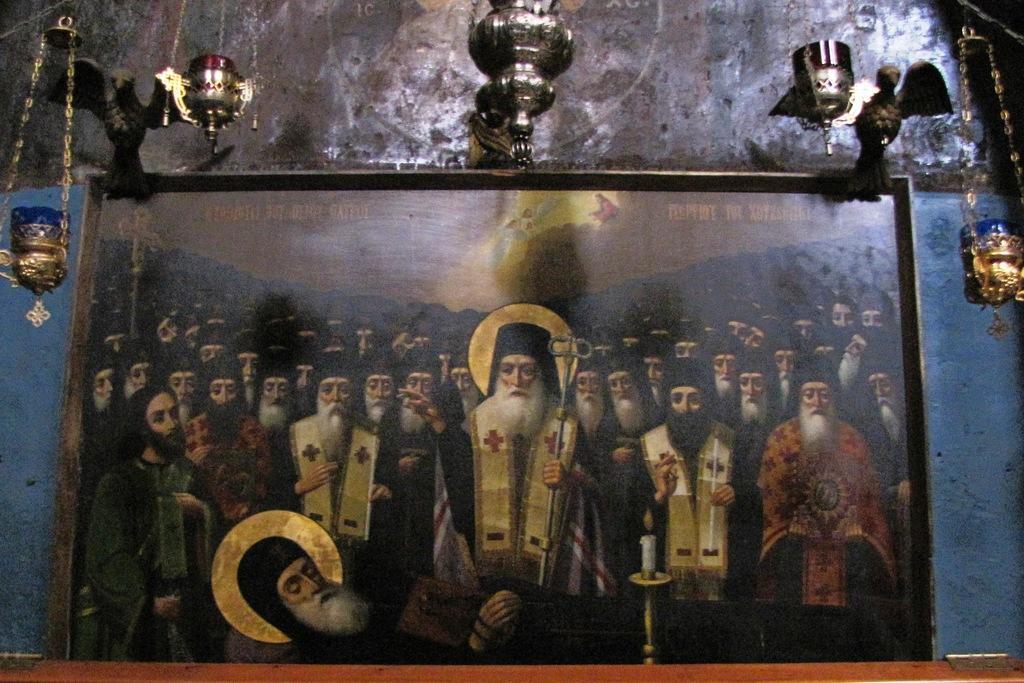In one or two sentences, can you explain what this image depicts? In the background of this picture we can see the wall and we can see the metal objects seems to be hanging on the wall and we can see the sculptures of birds. In the foreground we can see a picture frame containing the text and the depictions. In the foreground we can see a burning candle is placed on the top of the candle stand and we can see a person seems to be sitting. In the center there is a man wearing a costume, holding the metal object and seems to be standing. On the right there is another man holding some objects and standing and we can see the group of people seems to be standing on the ground. In the background we can see the sky and a person with feathers. On the right we can see another person and we can see some other objects in the background. 